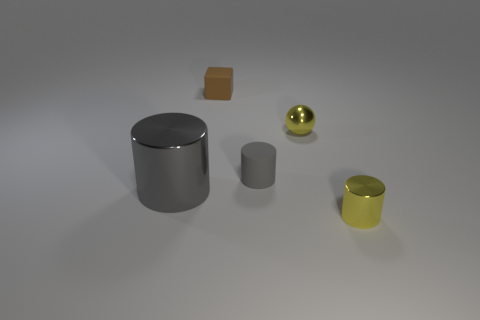Subtract all large cylinders. How many cylinders are left? 2 Add 3 large blue metallic cubes. How many objects exist? 8 Subtract 1 gray cylinders. How many objects are left? 4 Subtract all cubes. How many objects are left? 4 Subtract 1 blocks. How many blocks are left? 0 Subtract all purple cylinders. Subtract all blue blocks. How many cylinders are left? 3 Subtract all red cubes. How many yellow cylinders are left? 1 Subtract all gray rubber cubes. Subtract all tiny yellow things. How many objects are left? 3 Add 4 yellow shiny things. How many yellow shiny things are left? 6 Add 3 large gray cylinders. How many large gray cylinders exist? 4 